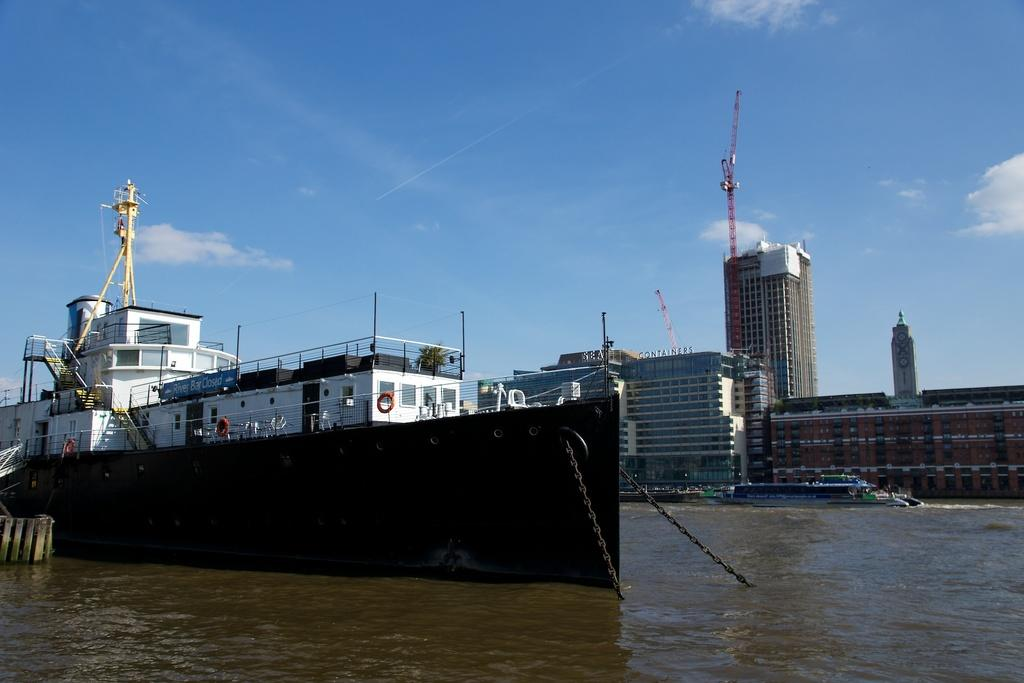What is the main subject in the foreground of the image? There is a ship in the foreground of the image. What is the ship's location in relation to the water? The ship is on the water. Are there any other ships visible in the image? Yes, there is another ship in the image. What can be seen in the background of the image? There are buildings, poles, and the sky visible in the background of the image. How many apples are being held by the father in the image? There is no father or apples present in the image. What type of pickle is being used as a navigational tool on the ship? There is no pickle present in the image, and pickles are not used as navigational tools. 